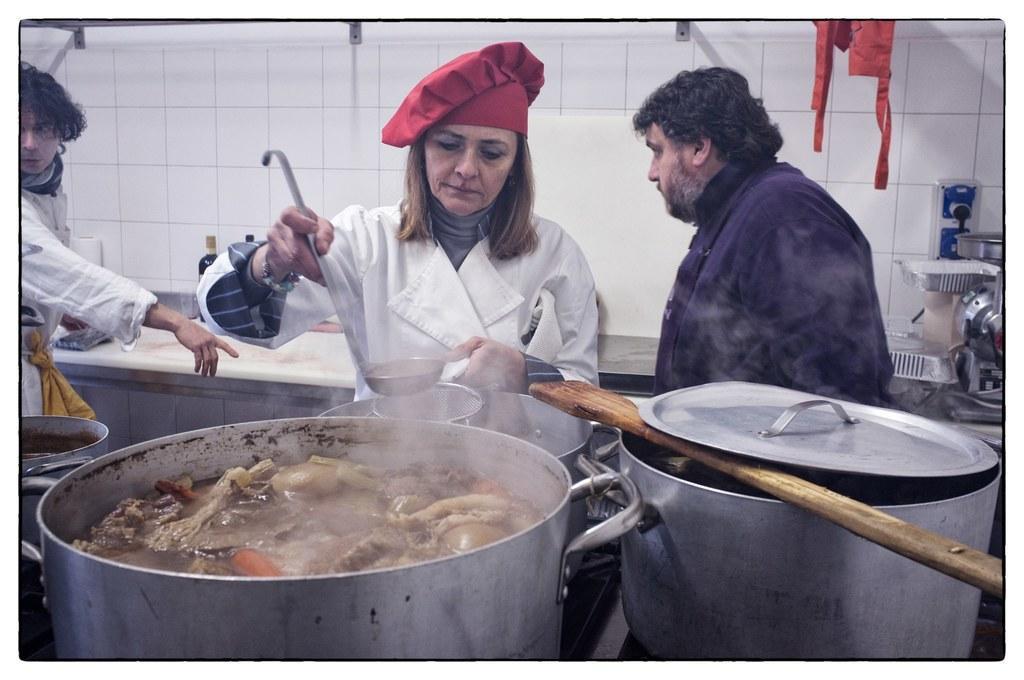In one or two sentences, can you explain what this image depicts? In this image we can see three persons standing. One woman is wearing a white dress and a red cap is holding a spoon in her and a bowl in other hands. In the foreground we can see three vessels containing food. To the right side, we can see a wooden spoon placed in a bowl. In the background, we can see some trays, place on the countertop along with some bottles. 